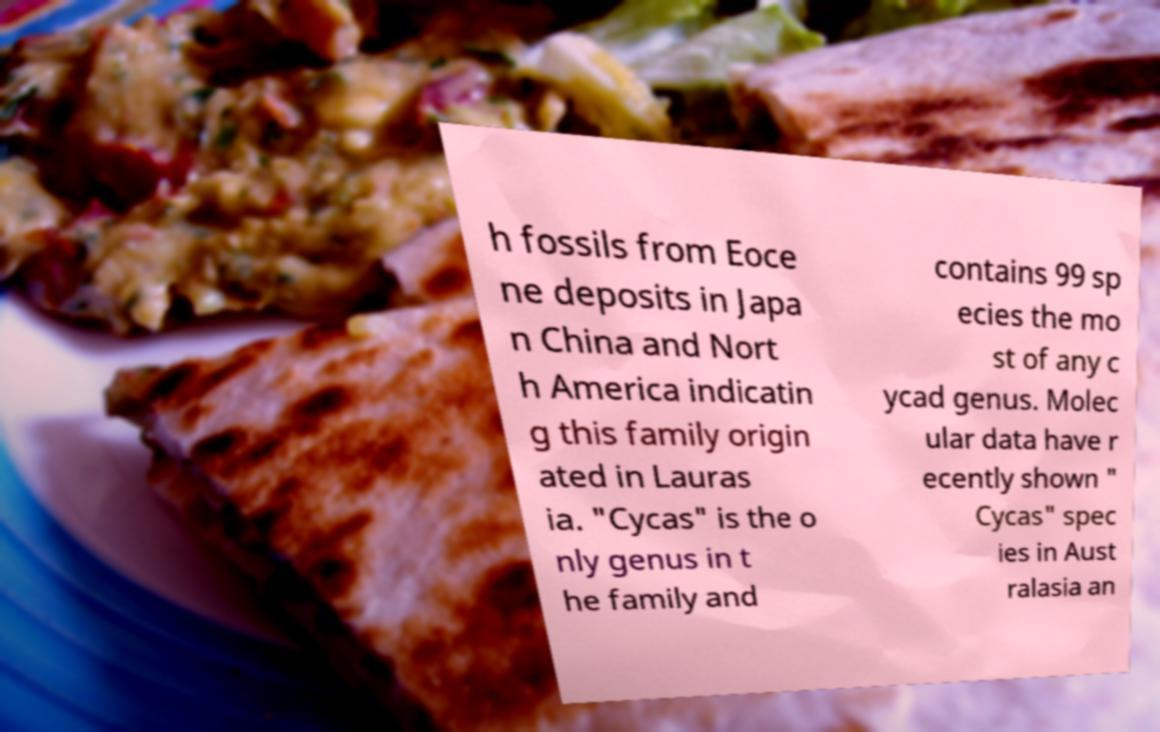I need the written content from this picture converted into text. Can you do that? h fossils from Eoce ne deposits in Japa n China and Nort h America indicatin g this family origin ated in Lauras ia. "Cycas" is the o nly genus in t he family and contains 99 sp ecies the mo st of any c ycad genus. Molec ular data have r ecently shown " Cycas" spec ies in Aust ralasia an 